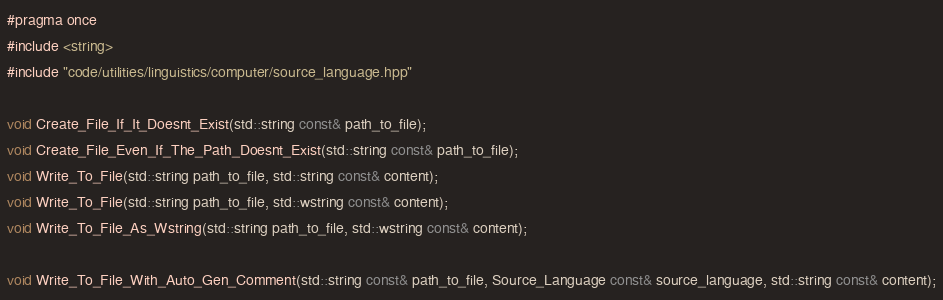Convert code to text. <code><loc_0><loc_0><loc_500><loc_500><_C++_>#pragma once
#include <string>
#include "code/utilities/linguistics/computer/source_language.hpp"

void Create_File_If_It_Doesnt_Exist(std::string const& path_to_file);
void Create_File_Even_If_The_Path_Doesnt_Exist(std::string const& path_to_file);
void Write_To_File(std::string path_to_file, std::string const& content);
void Write_To_File(std::string path_to_file, std::wstring const& content);
void Write_To_File_As_Wstring(std::string path_to_file, std::wstring const& content);

void Write_To_File_With_Auto_Gen_Comment(std::string const& path_to_file, Source_Language const& source_language, std::string const& content);
</code> 